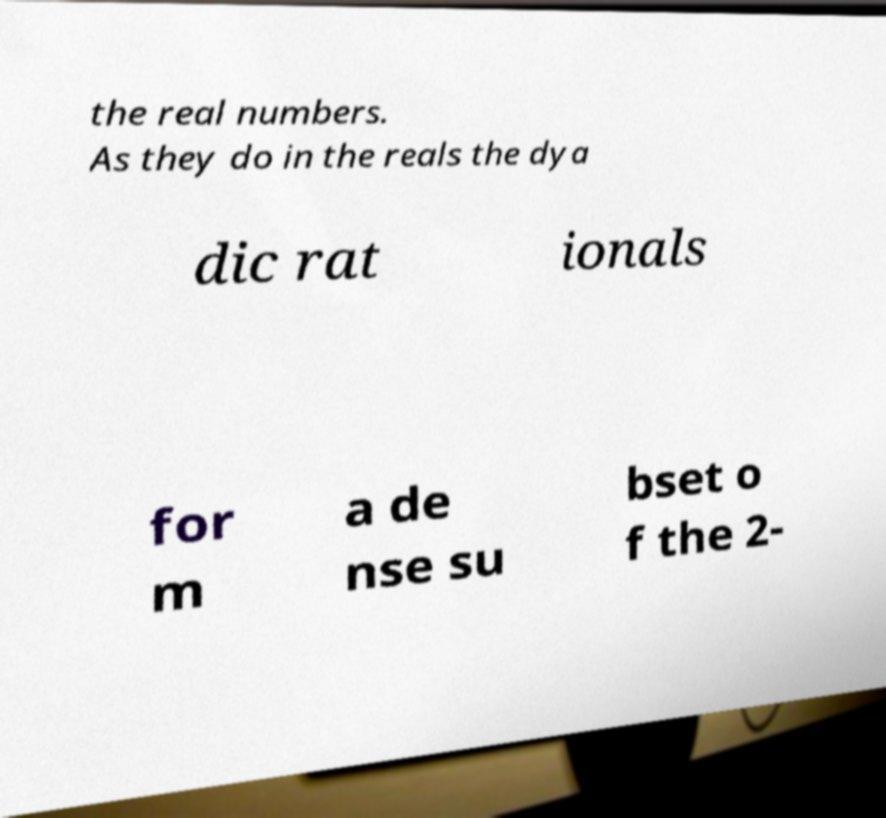For documentation purposes, I need the text within this image transcribed. Could you provide that? the real numbers. As they do in the reals the dya dic rat ionals for m a de nse su bset o f the 2- 